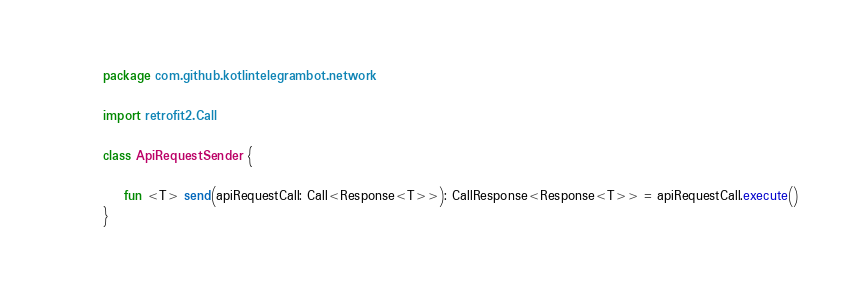Convert code to text. <code><loc_0><loc_0><loc_500><loc_500><_Kotlin_>package com.github.kotlintelegrambot.network

import retrofit2.Call

class ApiRequestSender {

    fun <T> send(apiRequestCall: Call<Response<T>>): CallResponse<Response<T>> = apiRequestCall.execute()
}
</code> 